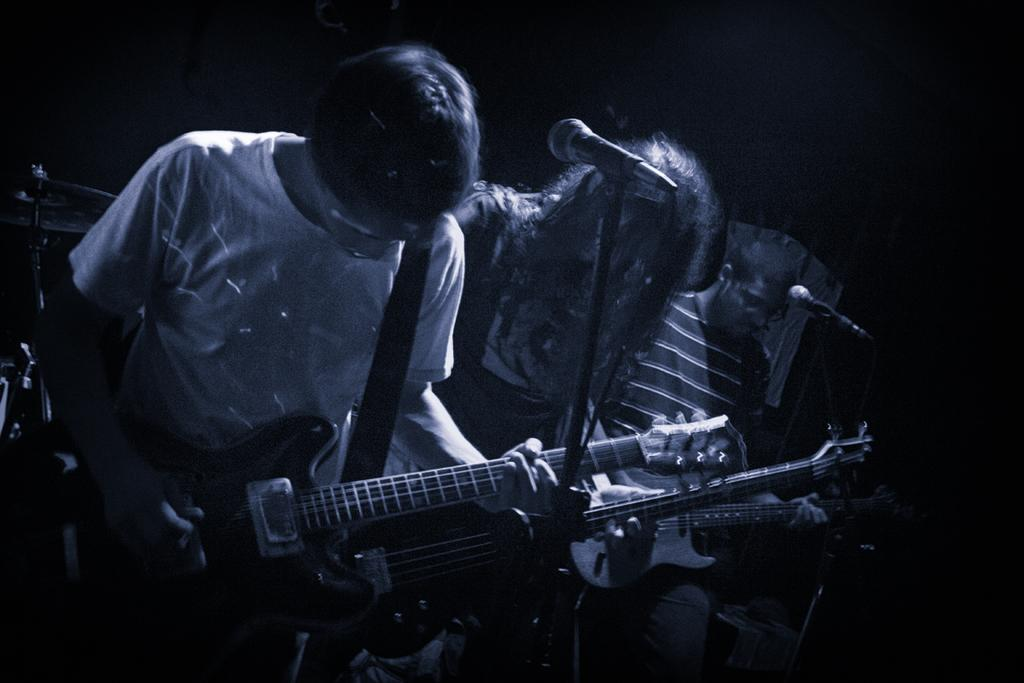How many people are in the image? There are three persons in the image. What are the persons holding in the image? Each person is holding a guitar. What other musical equipment can be seen in the image? There are microphones with stands and a cymbal on a stand in the image. What is the color of the background in the image? The background of the image is dark. What type of drug can be seen in the image? There is no drug present in the image. Is there a parcel being delivered in the image? There is no parcel delivery depicted in the image. 